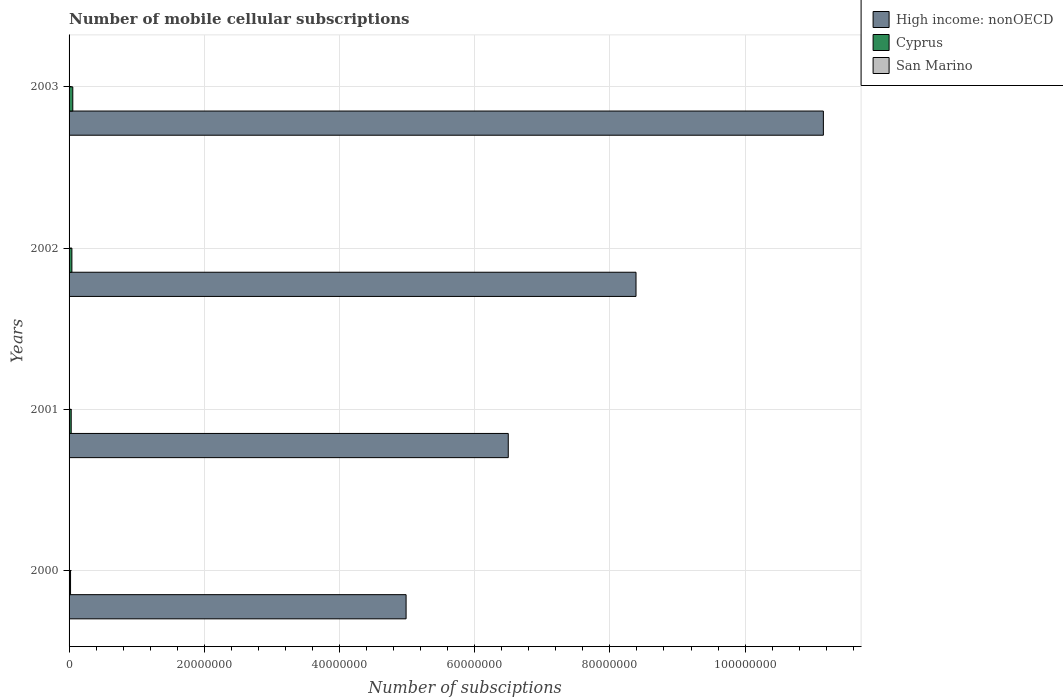How many different coloured bars are there?
Ensure brevity in your answer.  3. How many groups of bars are there?
Provide a succinct answer. 4. In how many cases, is the number of bars for a given year not equal to the number of legend labels?
Provide a succinct answer. 0. What is the number of mobile cellular subscriptions in San Marino in 2002?
Provide a short and direct response. 1.68e+04. Across all years, what is the maximum number of mobile cellular subscriptions in Cyprus?
Ensure brevity in your answer.  5.52e+05. Across all years, what is the minimum number of mobile cellular subscriptions in San Marino?
Provide a succinct answer. 1.45e+04. In which year was the number of mobile cellular subscriptions in High income: nonOECD minimum?
Give a very brief answer. 2000. What is the total number of mobile cellular subscriptions in Cyprus in the graph?
Offer a very short reply. 1.50e+06. What is the difference between the number of mobile cellular subscriptions in San Marino in 2002 and that in 2003?
Your answer should be compact. -141. What is the difference between the number of mobile cellular subscriptions in San Marino in 2000 and the number of mobile cellular subscriptions in Cyprus in 2001?
Give a very brief answer. -3.00e+05. What is the average number of mobile cellular subscriptions in Cyprus per year?
Give a very brief answer. 3.76e+05. In the year 2000, what is the difference between the number of mobile cellular subscriptions in High income: nonOECD and number of mobile cellular subscriptions in Cyprus?
Offer a very short reply. 4.96e+07. What is the ratio of the number of mobile cellular subscriptions in San Marino in 2000 to that in 2002?
Your answer should be compact. 0.87. Is the difference between the number of mobile cellular subscriptions in High income: nonOECD in 2000 and 2003 greater than the difference between the number of mobile cellular subscriptions in Cyprus in 2000 and 2003?
Provide a succinct answer. No. What is the difference between the highest and the second highest number of mobile cellular subscriptions in Cyprus?
Give a very brief answer. 1.34e+05. What is the difference between the highest and the lowest number of mobile cellular subscriptions in High income: nonOECD?
Make the answer very short. 6.17e+07. What does the 3rd bar from the top in 2001 represents?
Your answer should be very brief. High income: nonOECD. What does the 2nd bar from the bottom in 2000 represents?
Provide a short and direct response. Cyprus. How many bars are there?
Provide a short and direct response. 12. What is the difference between two consecutive major ticks on the X-axis?
Offer a terse response. 2.00e+07. Does the graph contain any zero values?
Make the answer very short. No. Where does the legend appear in the graph?
Provide a succinct answer. Top right. How many legend labels are there?
Make the answer very short. 3. How are the legend labels stacked?
Your answer should be very brief. Vertical. What is the title of the graph?
Keep it short and to the point. Number of mobile cellular subscriptions. What is the label or title of the X-axis?
Your answer should be compact. Number of subsciptions. What is the label or title of the Y-axis?
Offer a very short reply. Years. What is the Number of subsciptions of High income: nonOECD in 2000?
Provide a short and direct response. 4.99e+07. What is the Number of subsciptions of Cyprus in 2000?
Your answer should be compact. 2.18e+05. What is the Number of subsciptions of San Marino in 2000?
Your response must be concise. 1.45e+04. What is the Number of subsciptions in High income: nonOECD in 2001?
Offer a terse response. 6.50e+07. What is the Number of subsciptions of Cyprus in 2001?
Offer a terse response. 3.14e+05. What is the Number of subsciptions of San Marino in 2001?
Offer a very short reply. 1.59e+04. What is the Number of subsciptions of High income: nonOECD in 2002?
Your answer should be compact. 8.39e+07. What is the Number of subsciptions in Cyprus in 2002?
Your response must be concise. 4.18e+05. What is the Number of subsciptions in San Marino in 2002?
Ensure brevity in your answer.  1.68e+04. What is the Number of subsciptions in High income: nonOECD in 2003?
Your answer should be compact. 1.12e+08. What is the Number of subsciptions of Cyprus in 2003?
Provide a succinct answer. 5.52e+05. What is the Number of subsciptions in San Marino in 2003?
Make the answer very short. 1.69e+04. Across all years, what is the maximum Number of subsciptions in High income: nonOECD?
Keep it short and to the point. 1.12e+08. Across all years, what is the maximum Number of subsciptions in Cyprus?
Your response must be concise. 5.52e+05. Across all years, what is the maximum Number of subsciptions of San Marino?
Ensure brevity in your answer.  1.69e+04. Across all years, what is the minimum Number of subsciptions of High income: nonOECD?
Keep it short and to the point. 4.99e+07. Across all years, what is the minimum Number of subsciptions in Cyprus?
Offer a very short reply. 2.18e+05. Across all years, what is the minimum Number of subsciptions in San Marino?
Your answer should be compact. 1.45e+04. What is the total Number of subsciptions in High income: nonOECD in the graph?
Ensure brevity in your answer.  3.10e+08. What is the total Number of subsciptions in Cyprus in the graph?
Provide a succinct answer. 1.50e+06. What is the total Number of subsciptions in San Marino in the graph?
Your answer should be compact. 6.40e+04. What is the difference between the Number of subsciptions of High income: nonOECD in 2000 and that in 2001?
Make the answer very short. -1.51e+07. What is the difference between the Number of subsciptions in Cyprus in 2000 and that in 2001?
Give a very brief answer. -9.60e+04. What is the difference between the Number of subsciptions in San Marino in 2000 and that in 2001?
Offer a very short reply. -1351. What is the difference between the Number of subsciptions of High income: nonOECD in 2000 and that in 2002?
Give a very brief answer. -3.40e+07. What is the difference between the Number of subsciptions in Cyprus in 2000 and that in 2002?
Give a very brief answer. -2.00e+05. What is the difference between the Number of subsciptions in San Marino in 2000 and that in 2002?
Your answer should be very brief. -2256. What is the difference between the Number of subsciptions of High income: nonOECD in 2000 and that in 2003?
Keep it short and to the point. -6.17e+07. What is the difference between the Number of subsciptions in Cyprus in 2000 and that in 2003?
Ensure brevity in your answer.  -3.33e+05. What is the difference between the Number of subsciptions of San Marino in 2000 and that in 2003?
Your answer should be compact. -2397. What is the difference between the Number of subsciptions of High income: nonOECD in 2001 and that in 2002?
Give a very brief answer. -1.89e+07. What is the difference between the Number of subsciptions of Cyprus in 2001 and that in 2002?
Provide a short and direct response. -1.04e+05. What is the difference between the Number of subsciptions in San Marino in 2001 and that in 2002?
Provide a succinct answer. -905. What is the difference between the Number of subsciptions of High income: nonOECD in 2001 and that in 2003?
Make the answer very short. -4.66e+07. What is the difference between the Number of subsciptions in Cyprus in 2001 and that in 2003?
Offer a very short reply. -2.37e+05. What is the difference between the Number of subsciptions of San Marino in 2001 and that in 2003?
Provide a succinct answer. -1046. What is the difference between the Number of subsciptions of High income: nonOECD in 2002 and that in 2003?
Your response must be concise. -2.77e+07. What is the difference between the Number of subsciptions of Cyprus in 2002 and that in 2003?
Your answer should be compact. -1.34e+05. What is the difference between the Number of subsciptions of San Marino in 2002 and that in 2003?
Provide a short and direct response. -141. What is the difference between the Number of subsciptions of High income: nonOECD in 2000 and the Number of subsciptions of Cyprus in 2001?
Give a very brief answer. 4.95e+07. What is the difference between the Number of subsciptions of High income: nonOECD in 2000 and the Number of subsciptions of San Marino in 2001?
Make the answer very short. 4.98e+07. What is the difference between the Number of subsciptions of Cyprus in 2000 and the Number of subsciptions of San Marino in 2001?
Give a very brief answer. 2.02e+05. What is the difference between the Number of subsciptions in High income: nonOECD in 2000 and the Number of subsciptions in Cyprus in 2002?
Make the answer very short. 4.94e+07. What is the difference between the Number of subsciptions in High income: nonOECD in 2000 and the Number of subsciptions in San Marino in 2002?
Ensure brevity in your answer.  4.98e+07. What is the difference between the Number of subsciptions of Cyprus in 2000 and the Number of subsciptions of San Marino in 2002?
Make the answer very short. 2.02e+05. What is the difference between the Number of subsciptions in High income: nonOECD in 2000 and the Number of subsciptions in Cyprus in 2003?
Ensure brevity in your answer.  4.93e+07. What is the difference between the Number of subsciptions of High income: nonOECD in 2000 and the Number of subsciptions of San Marino in 2003?
Give a very brief answer. 4.98e+07. What is the difference between the Number of subsciptions of Cyprus in 2000 and the Number of subsciptions of San Marino in 2003?
Give a very brief answer. 2.01e+05. What is the difference between the Number of subsciptions of High income: nonOECD in 2001 and the Number of subsciptions of Cyprus in 2002?
Your response must be concise. 6.46e+07. What is the difference between the Number of subsciptions in High income: nonOECD in 2001 and the Number of subsciptions in San Marino in 2002?
Offer a terse response. 6.50e+07. What is the difference between the Number of subsciptions of Cyprus in 2001 and the Number of subsciptions of San Marino in 2002?
Your answer should be very brief. 2.98e+05. What is the difference between the Number of subsciptions in High income: nonOECD in 2001 and the Number of subsciptions in Cyprus in 2003?
Keep it short and to the point. 6.44e+07. What is the difference between the Number of subsciptions in High income: nonOECD in 2001 and the Number of subsciptions in San Marino in 2003?
Provide a succinct answer. 6.50e+07. What is the difference between the Number of subsciptions of Cyprus in 2001 and the Number of subsciptions of San Marino in 2003?
Your answer should be compact. 2.97e+05. What is the difference between the Number of subsciptions of High income: nonOECD in 2002 and the Number of subsciptions of Cyprus in 2003?
Make the answer very short. 8.33e+07. What is the difference between the Number of subsciptions in High income: nonOECD in 2002 and the Number of subsciptions in San Marino in 2003?
Offer a very short reply. 8.38e+07. What is the difference between the Number of subsciptions of Cyprus in 2002 and the Number of subsciptions of San Marino in 2003?
Provide a short and direct response. 4.01e+05. What is the average Number of subsciptions of High income: nonOECD per year?
Offer a terse response. 7.76e+07. What is the average Number of subsciptions of Cyprus per year?
Make the answer very short. 3.76e+05. What is the average Number of subsciptions of San Marino per year?
Your response must be concise. 1.60e+04. In the year 2000, what is the difference between the Number of subsciptions in High income: nonOECD and Number of subsciptions in Cyprus?
Ensure brevity in your answer.  4.96e+07. In the year 2000, what is the difference between the Number of subsciptions of High income: nonOECD and Number of subsciptions of San Marino?
Ensure brevity in your answer.  4.98e+07. In the year 2000, what is the difference between the Number of subsciptions in Cyprus and Number of subsciptions in San Marino?
Give a very brief answer. 2.04e+05. In the year 2001, what is the difference between the Number of subsciptions of High income: nonOECD and Number of subsciptions of Cyprus?
Give a very brief answer. 6.47e+07. In the year 2001, what is the difference between the Number of subsciptions of High income: nonOECD and Number of subsciptions of San Marino?
Offer a terse response. 6.50e+07. In the year 2001, what is the difference between the Number of subsciptions in Cyprus and Number of subsciptions in San Marino?
Your response must be concise. 2.99e+05. In the year 2002, what is the difference between the Number of subsciptions in High income: nonOECD and Number of subsciptions in Cyprus?
Offer a terse response. 8.34e+07. In the year 2002, what is the difference between the Number of subsciptions of High income: nonOECD and Number of subsciptions of San Marino?
Give a very brief answer. 8.38e+07. In the year 2002, what is the difference between the Number of subsciptions of Cyprus and Number of subsciptions of San Marino?
Give a very brief answer. 4.01e+05. In the year 2003, what is the difference between the Number of subsciptions in High income: nonOECD and Number of subsciptions in Cyprus?
Give a very brief answer. 1.11e+08. In the year 2003, what is the difference between the Number of subsciptions of High income: nonOECD and Number of subsciptions of San Marino?
Offer a terse response. 1.12e+08. In the year 2003, what is the difference between the Number of subsciptions of Cyprus and Number of subsciptions of San Marino?
Ensure brevity in your answer.  5.35e+05. What is the ratio of the Number of subsciptions of High income: nonOECD in 2000 to that in 2001?
Make the answer very short. 0.77. What is the ratio of the Number of subsciptions of Cyprus in 2000 to that in 2001?
Your response must be concise. 0.69. What is the ratio of the Number of subsciptions of San Marino in 2000 to that in 2001?
Your answer should be very brief. 0.91. What is the ratio of the Number of subsciptions of High income: nonOECD in 2000 to that in 2002?
Your answer should be compact. 0.59. What is the ratio of the Number of subsciptions in Cyprus in 2000 to that in 2002?
Keep it short and to the point. 0.52. What is the ratio of the Number of subsciptions of San Marino in 2000 to that in 2002?
Give a very brief answer. 0.87. What is the ratio of the Number of subsciptions in High income: nonOECD in 2000 to that in 2003?
Offer a very short reply. 0.45. What is the ratio of the Number of subsciptions in Cyprus in 2000 to that in 2003?
Make the answer very short. 0.4. What is the ratio of the Number of subsciptions of San Marino in 2000 to that in 2003?
Your answer should be compact. 0.86. What is the ratio of the Number of subsciptions of High income: nonOECD in 2001 to that in 2002?
Your answer should be very brief. 0.77. What is the ratio of the Number of subsciptions in Cyprus in 2001 to that in 2002?
Provide a succinct answer. 0.75. What is the ratio of the Number of subsciptions in San Marino in 2001 to that in 2002?
Your response must be concise. 0.95. What is the ratio of the Number of subsciptions of High income: nonOECD in 2001 to that in 2003?
Offer a very short reply. 0.58. What is the ratio of the Number of subsciptions of Cyprus in 2001 to that in 2003?
Provide a succinct answer. 0.57. What is the ratio of the Number of subsciptions of San Marino in 2001 to that in 2003?
Offer a terse response. 0.94. What is the ratio of the Number of subsciptions of High income: nonOECD in 2002 to that in 2003?
Provide a short and direct response. 0.75. What is the ratio of the Number of subsciptions in Cyprus in 2002 to that in 2003?
Make the answer very short. 0.76. What is the difference between the highest and the second highest Number of subsciptions in High income: nonOECD?
Offer a terse response. 2.77e+07. What is the difference between the highest and the second highest Number of subsciptions in Cyprus?
Your answer should be very brief. 1.34e+05. What is the difference between the highest and the second highest Number of subsciptions of San Marino?
Your answer should be very brief. 141. What is the difference between the highest and the lowest Number of subsciptions in High income: nonOECD?
Your answer should be compact. 6.17e+07. What is the difference between the highest and the lowest Number of subsciptions of Cyprus?
Your response must be concise. 3.33e+05. What is the difference between the highest and the lowest Number of subsciptions of San Marino?
Ensure brevity in your answer.  2397. 